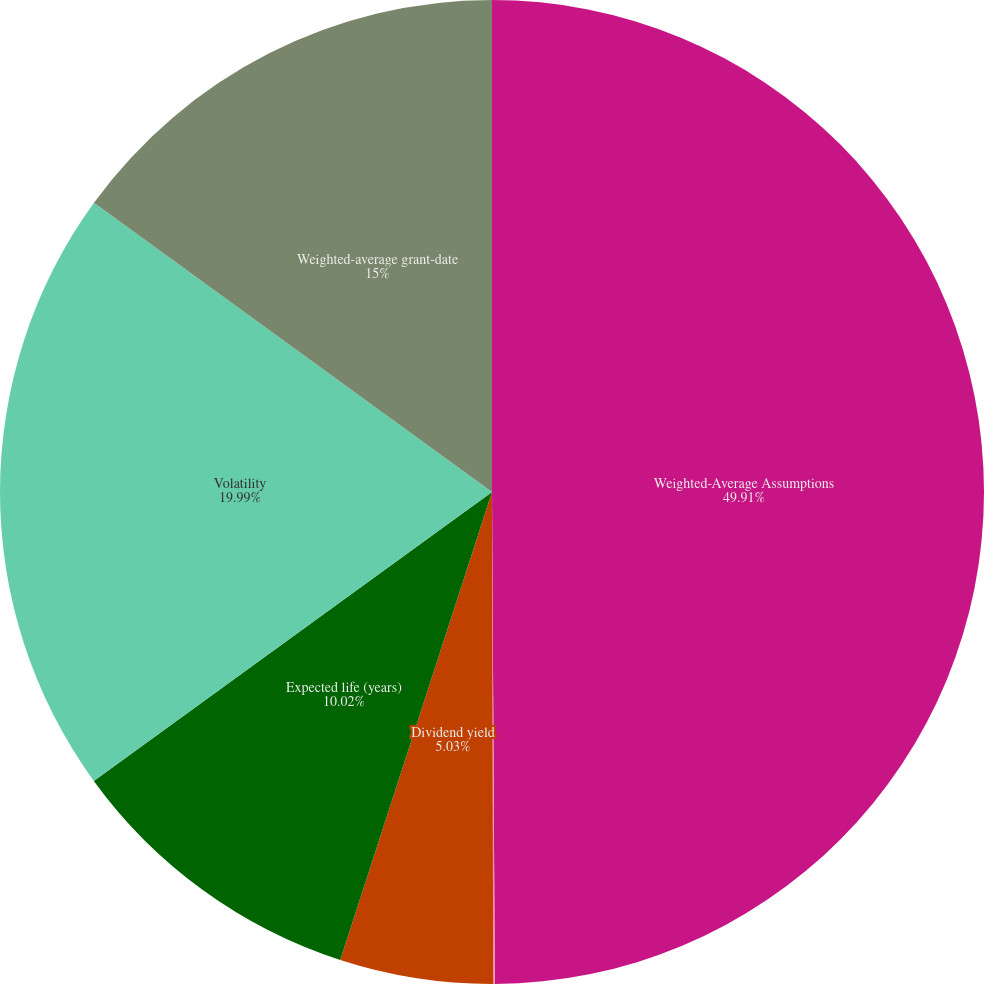Convert chart to OTSL. <chart><loc_0><loc_0><loc_500><loc_500><pie_chart><fcel>Weighted-Average Assumptions<fcel>Risk-free interest rate<fcel>Dividend yield<fcel>Expected life (years)<fcel>Volatility<fcel>Weighted-average grant-date<nl><fcel>49.91%<fcel>0.05%<fcel>5.03%<fcel>10.02%<fcel>19.99%<fcel>15.0%<nl></chart> 